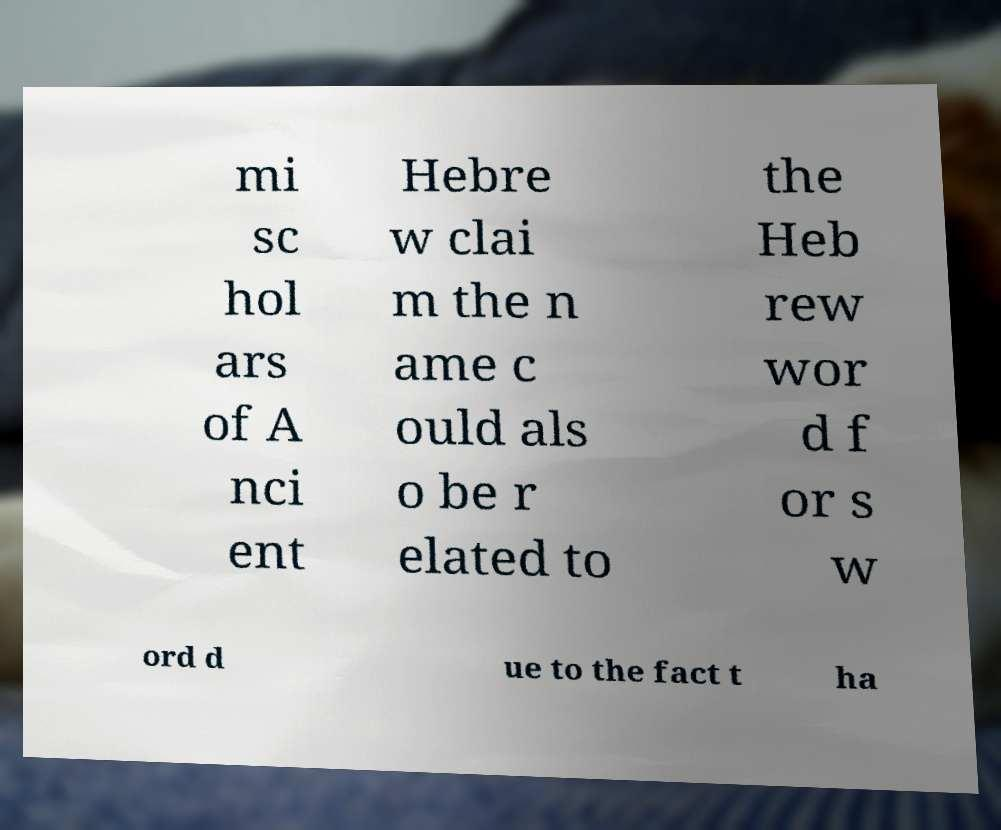Please identify and transcribe the text found in this image. mi sc hol ars of A nci ent Hebre w clai m the n ame c ould als o be r elated to the Heb rew wor d f or s w ord d ue to the fact t ha 